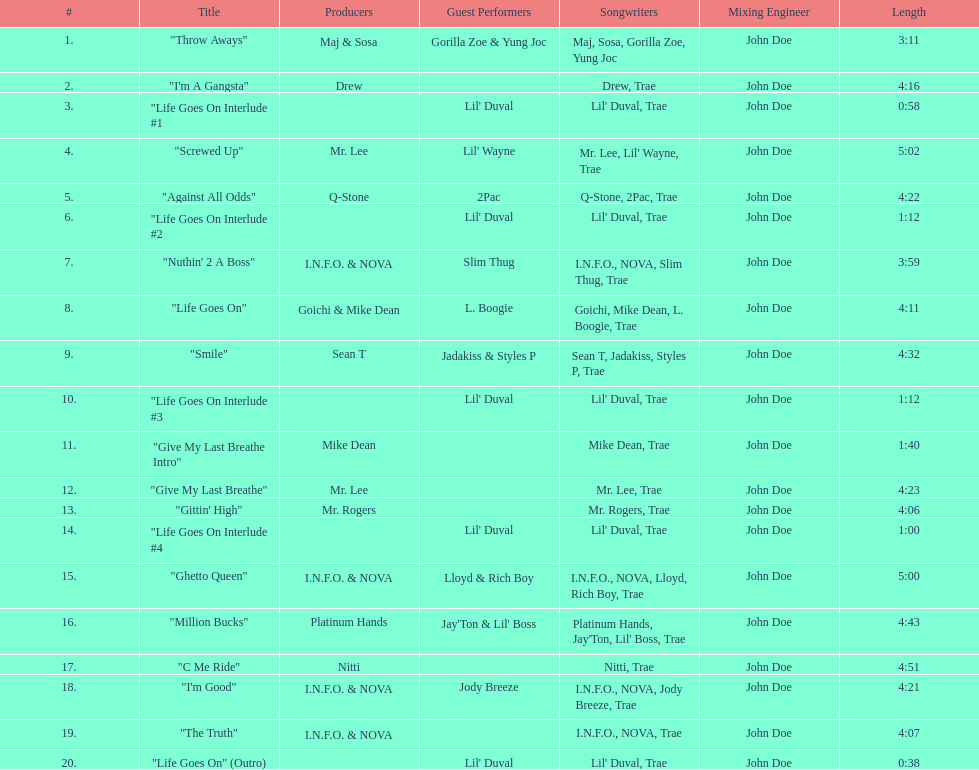What is the first track featuring lil' duval? "Life Goes On Interlude #1. 